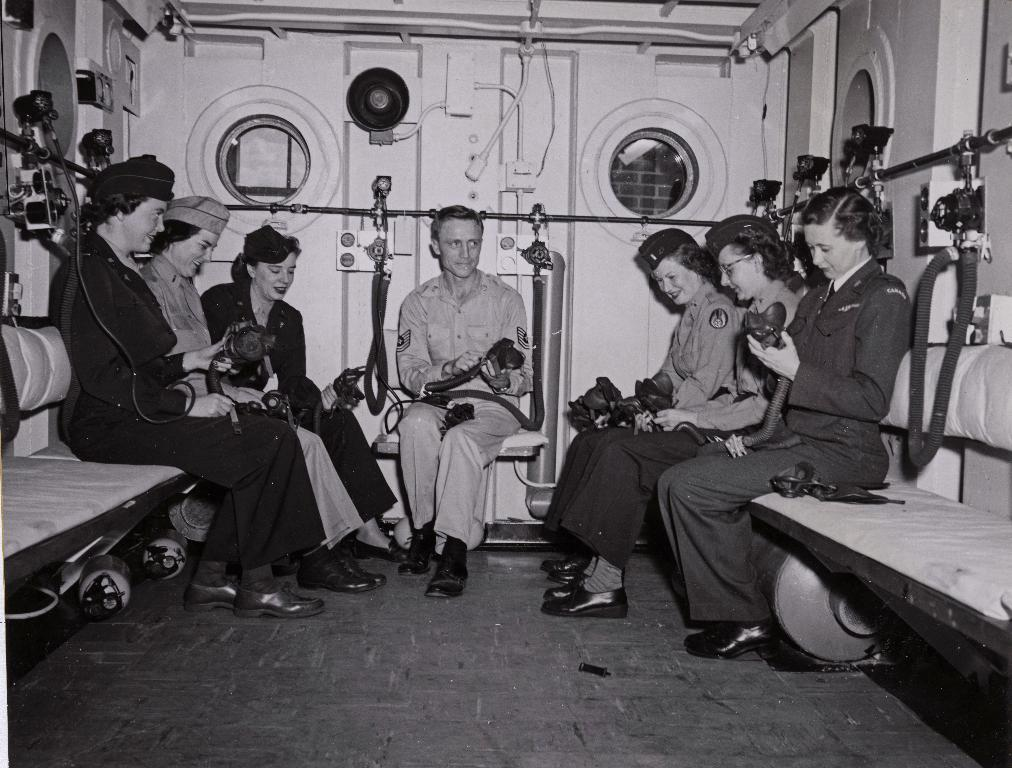What are the persons in the image doing? The persons in the image are sitting. What can be seen on the persons in the image? There are black belts visible on the persons in the image. What is visible through the windows in the image? The presence of windows suggests that there is a view or scenery visible through them, but the specifics are not mentioned in the facts. What type of object is the black pipe in the image? The facts do not specify the type of black pipe, so we cannot determine its exact nature. What color are the eyes of the person sitting in the image? The facts do not mention the color of anyone's eyes in the image, so we cannot determine the color of their eyes. What type of paper is being used by the person sitting in the image? There is no paper present in the image, so we cannot determine what type of paper might be used. 